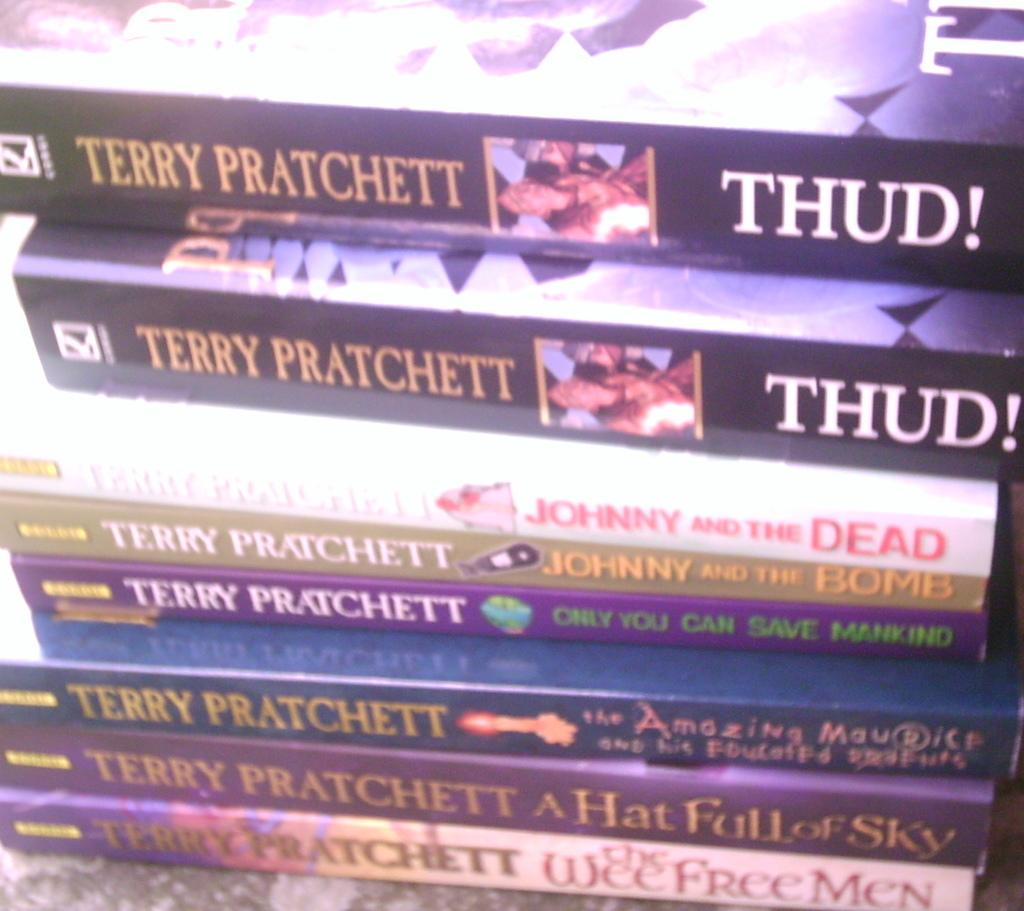<image>
Give a short and clear explanation of the subsequent image. Book titled "Thud!" by Terry Pratchett on top of other books. 